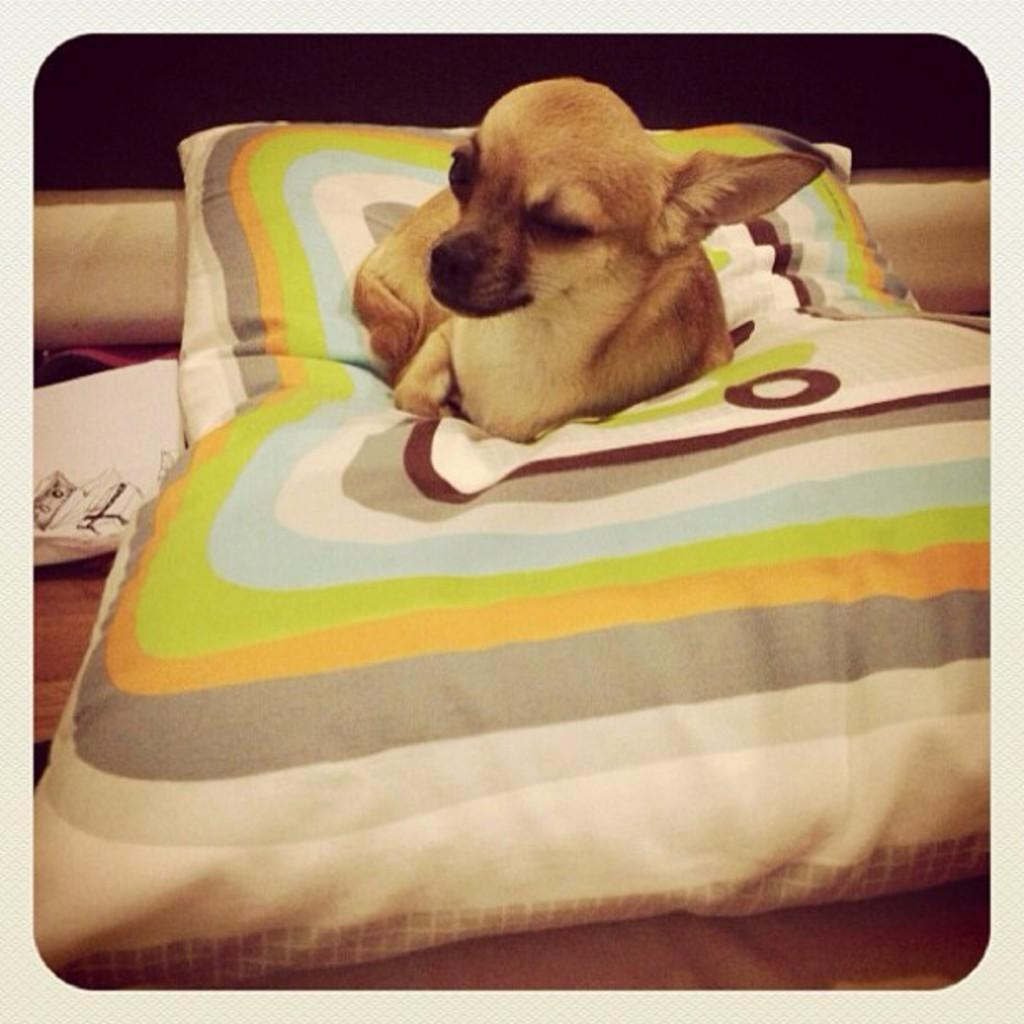What type of animal is present in the image? There is a dog in the image. Where is the dog located in the image? The dog is sitting on a pillow. What type of discussion is taking place between the dog and the sink in the image? There is no sink present in the image, and therefore no discussion can be observed between the dog and a sink. 